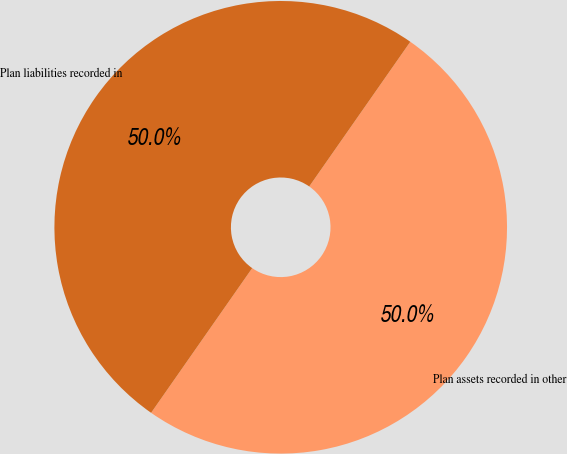<chart> <loc_0><loc_0><loc_500><loc_500><pie_chart><fcel>Plan assets recorded in other<fcel>Plan liabilities recorded in<nl><fcel>50.0%<fcel>50.0%<nl></chart> 